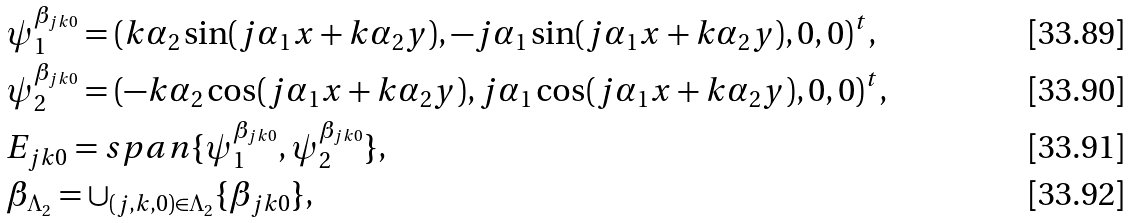<formula> <loc_0><loc_0><loc_500><loc_500>& \psi ^ { \beta _ { j k 0 } } _ { 1 } = ( k \alpha _ { 2 } \sin ( j \alpha _ { 1 } x + k \alpha _ { 2 } y ) , - j \alpha _ { 1 } \sin ( j \alpha _ { 1 } x + k \alpha _ { 2 } y ) , 0 , 0 ) ^ { t } , \\ & \psi ^ { \beta _ { j k 0 } } _ { 2 } = ( - k \alpha _ { 2 } \cos ( j \alpha _ { 1 } x + k \alpha _ { 2 } y ) , j \alpha _ { 1 } \cos ( j \alpha _ { 1 } x + k \alpha _ { 2 } y ) , 0 , 0 ) ^ { t } , \\ & E _ { j k 0 } = s p a n \{ \psi ^ { \beta _ { j k 0 } } _ { 1 } , \psi ^ { \beta _ { j k 0 } } _ { 2 } \} , \\ & \beta _ { \Lambda _ { 2 } } = \cup _ { ( j , k , 0 ) \in \Lambda _ { 2 } } \{ \beta _ { j k 0 } \} ,</formula> 